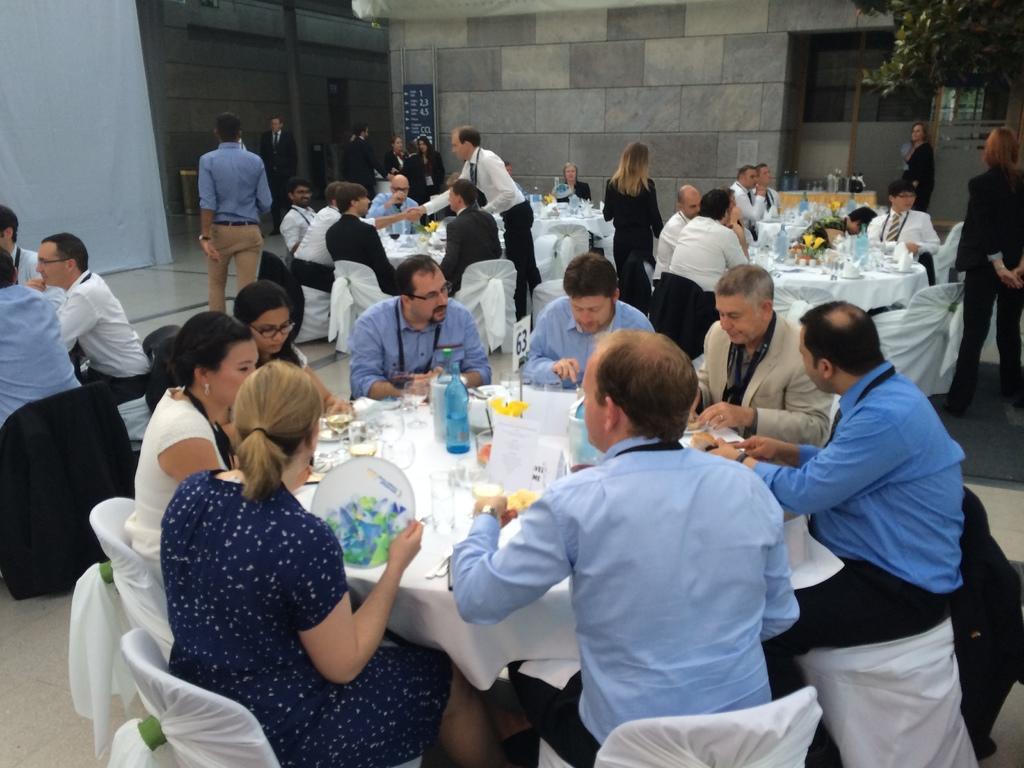Describe this image in one or two sentences. In this image I can see few people are sitting on the chairs around the tables which are covered with white clothes. On the table I can I can see few glasses, bottles and plates. On the right top of the image there is a tree. In the background I can see a building. On the left top of the image there is a curtain. 